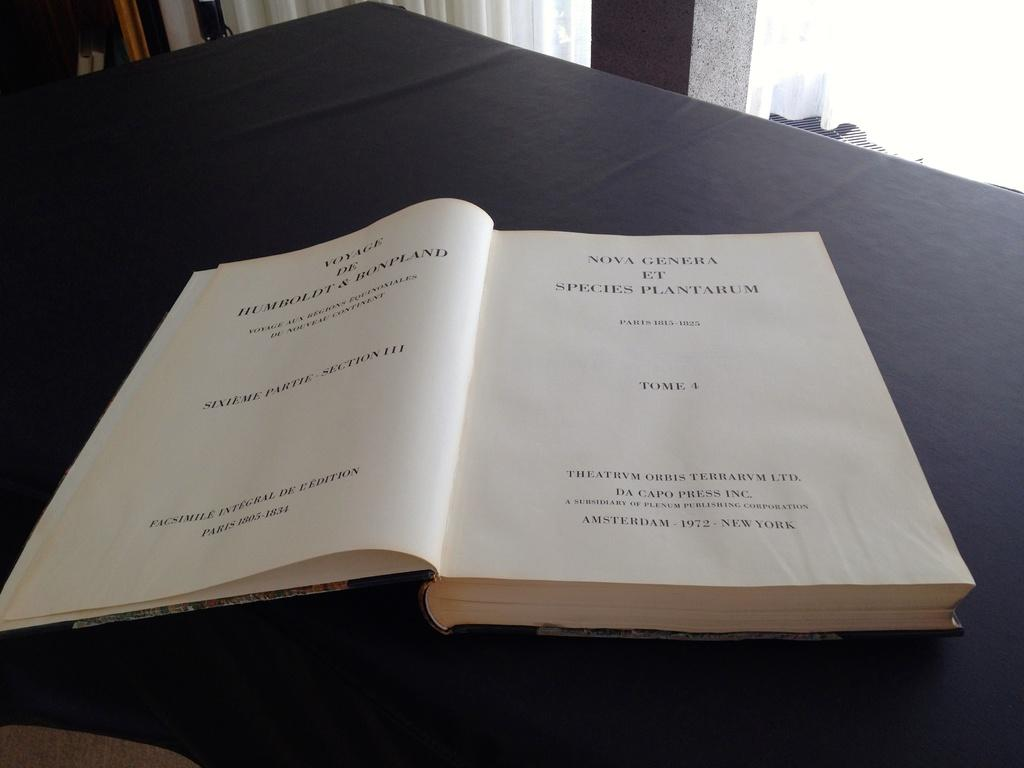<image>
Create a compact narrative representing the image presented. Nova Genera Et species plantarum chapter book that is open 